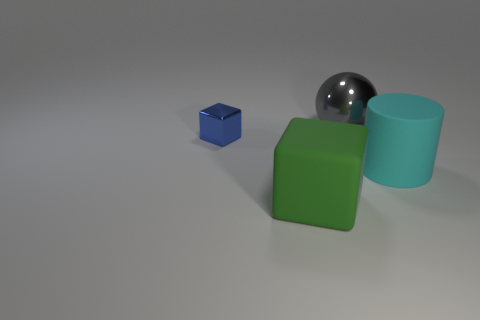Subtract all cyan balls. Subtract all cyan cylinders. How many balls are left? 1 Add 3 balls. How many objects exist? 7 Subtract all spheres. How many objects are left? 3 Add 4 large cubes. How many large cubes are left? 5 Add 4 large brown shiny cylinders. How many large brown shiny cylinders exist? 4 Subtract 0 brown spheres. How many objects are left? 4 Subtract all large gray rubber balls. Subtract all big things. How many objects are left? 1 